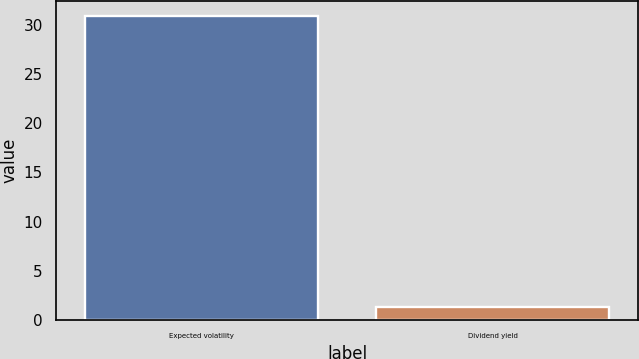Convert chart to OTSL. <chart><loc_0><loc_0><loc_500><loc_500><bar_chart><fcel>Expected volatility<fcel>Dividend yield<nl><fcel>30.9<fcel>1.3<nl></chart> 